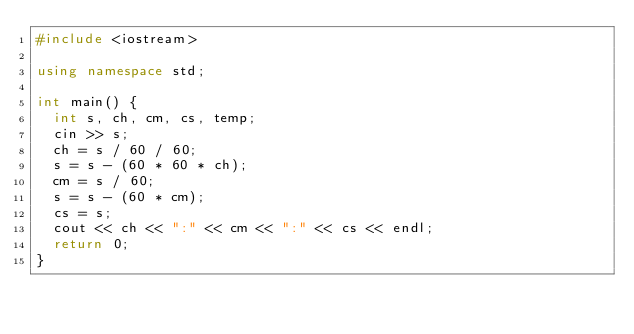<code> <loc_0><loc_0><loc_500><loc_500><_C++_>#include <iostream>

using namespace std;

int main() {
	int s, ch, cm, cs, temp;
	cin >> s;
	ch = s / 60 / 60;
	s = s - (60 * 60 * ch);
	cm = s / 60;
	s = s - (60 * cm);
	cs = s;
	cout << ch << ":" << cm << ":" << cs << endl;
	return 0;
}
</code> 